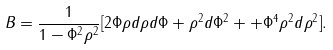Convert formula to latex. <formula><loc_0><loc_0><loc_500><loc_500>B = \frac { 1 } { 1 - \Phi ^ { 2 } \rho ^ { 2 } } [ 2 \Phi \rho d \rho d \Phi + \rho ^ { 2 } d \Phi ^ { 2 } + + \Phi ^ { 4 } \rho ^ { 2 } d \rho ^ { 2 } ] .</formula> 